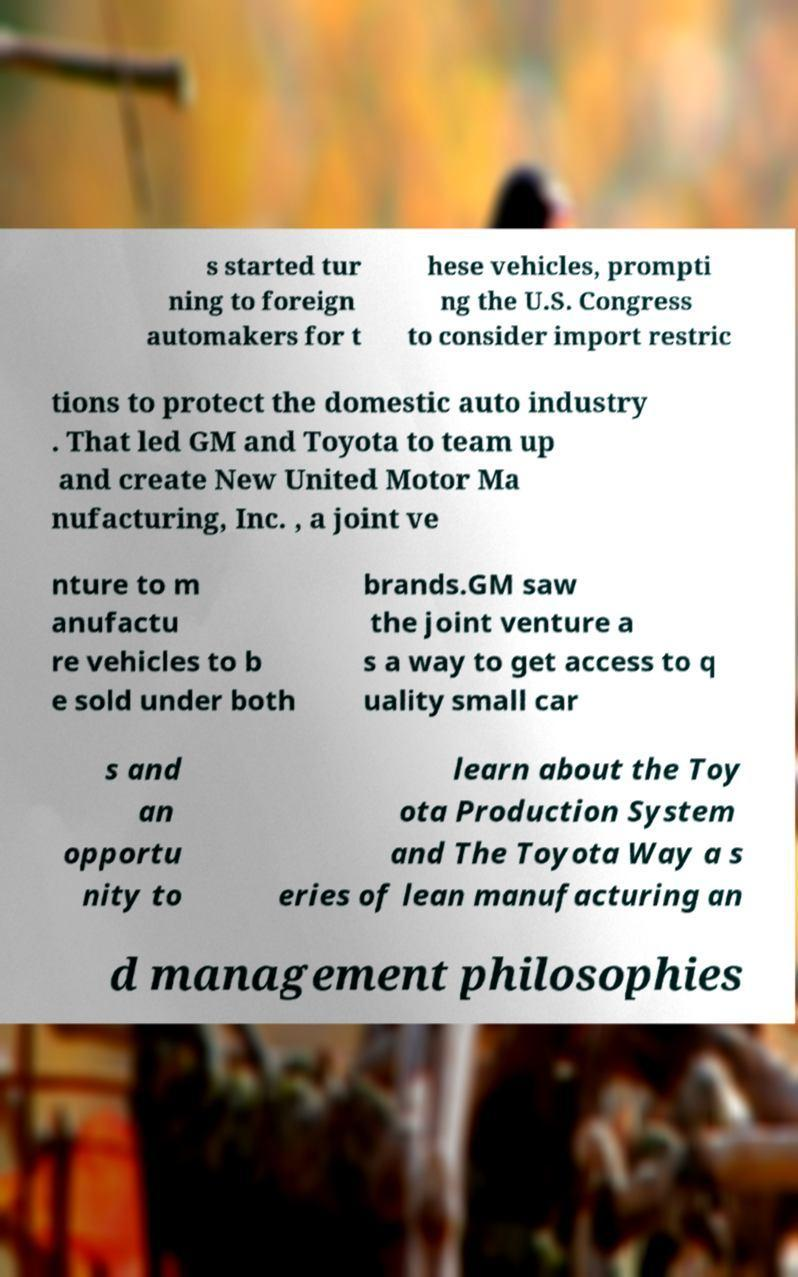Could you assist in decoding the text presented in this image and type it out clearly? s started tur ning to foreign automakers for t hese vehicles, prompti ng the U.S. Congress to consider import restric tions to protect the domestic auto industry . That led GM and Toyota to team up and create New United Motor Ma nufacturing, Inc. , a joint ve nture to m anufactu re vehicles to b e sold under both brands.GM saw the joint venture a s a way to get access to q uality small car s and an opportu nity to learn about the Toy ota Production System and The Toyota Way a s eries of lean manufacturing an d management philosophies 